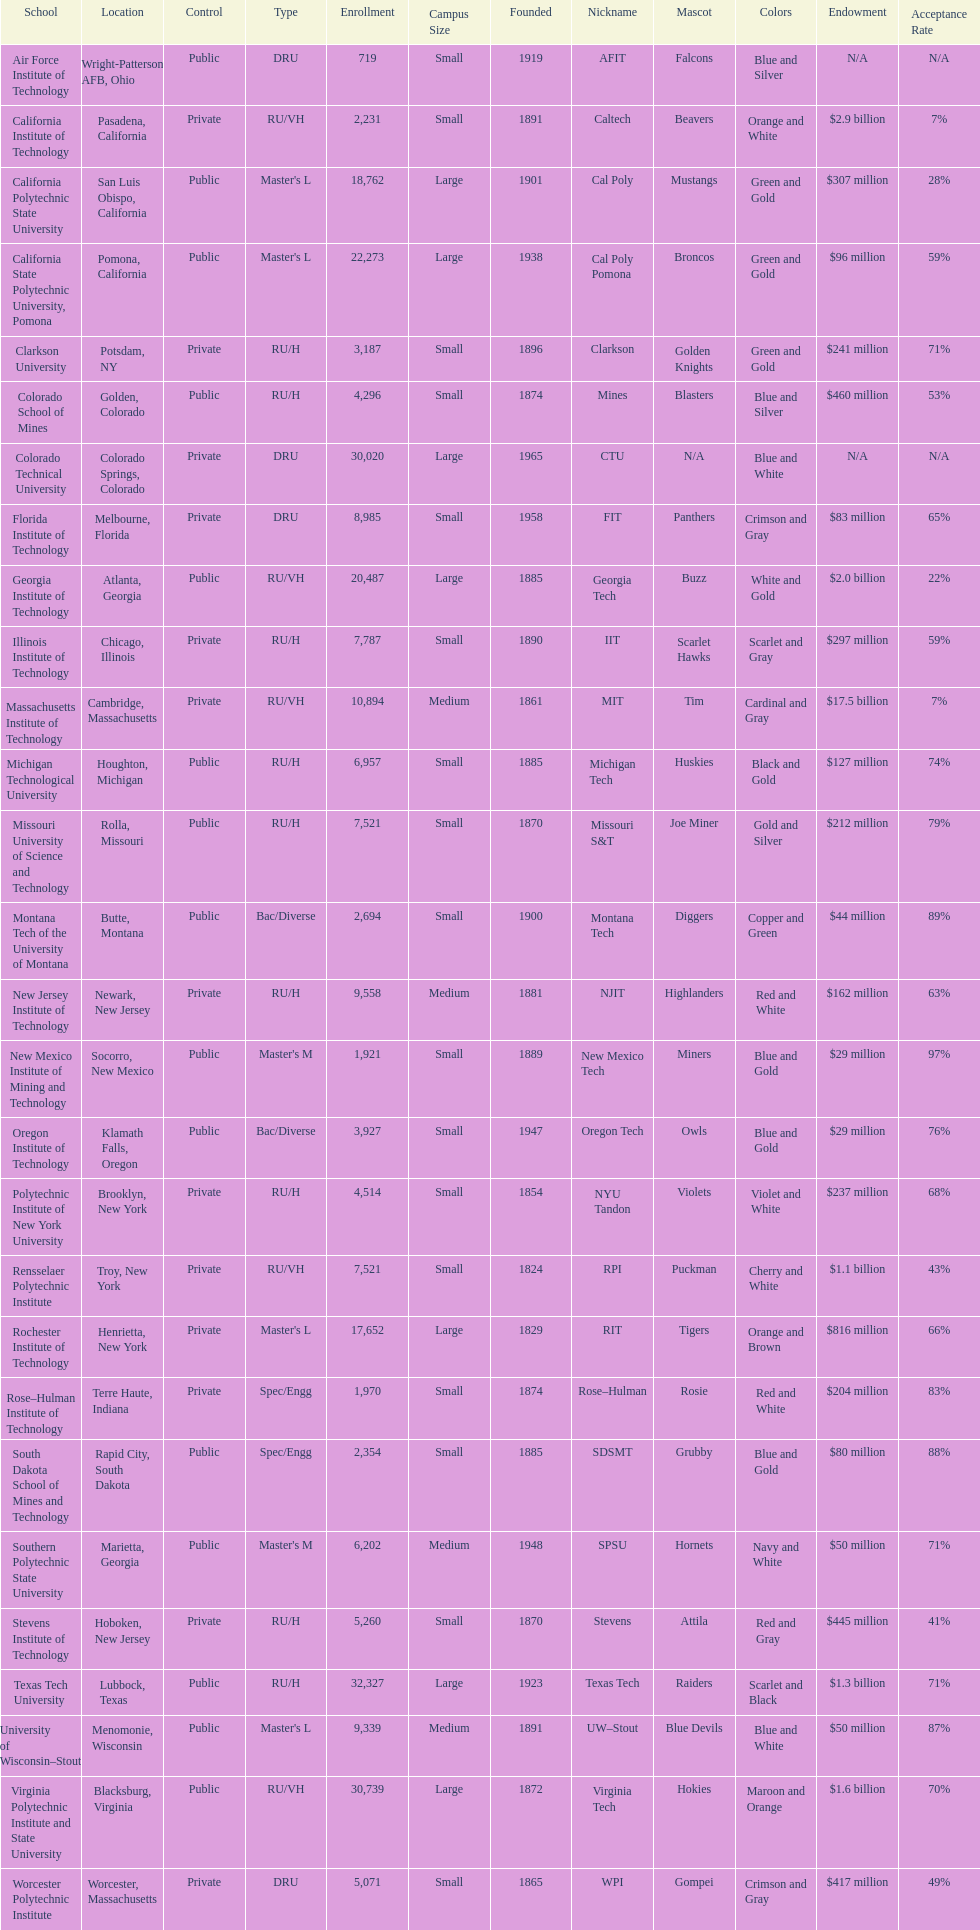What is the disparity in enrolment between the two leading schools displayed in the table? 1512. 